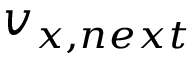<formula> <loc_0><loc_0><loc_500><loc_500>v _ { x , n e x t }</formula> 